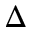<formula> <loc_0><loc_0><loc_500><loc_500>\Delta</formula> 